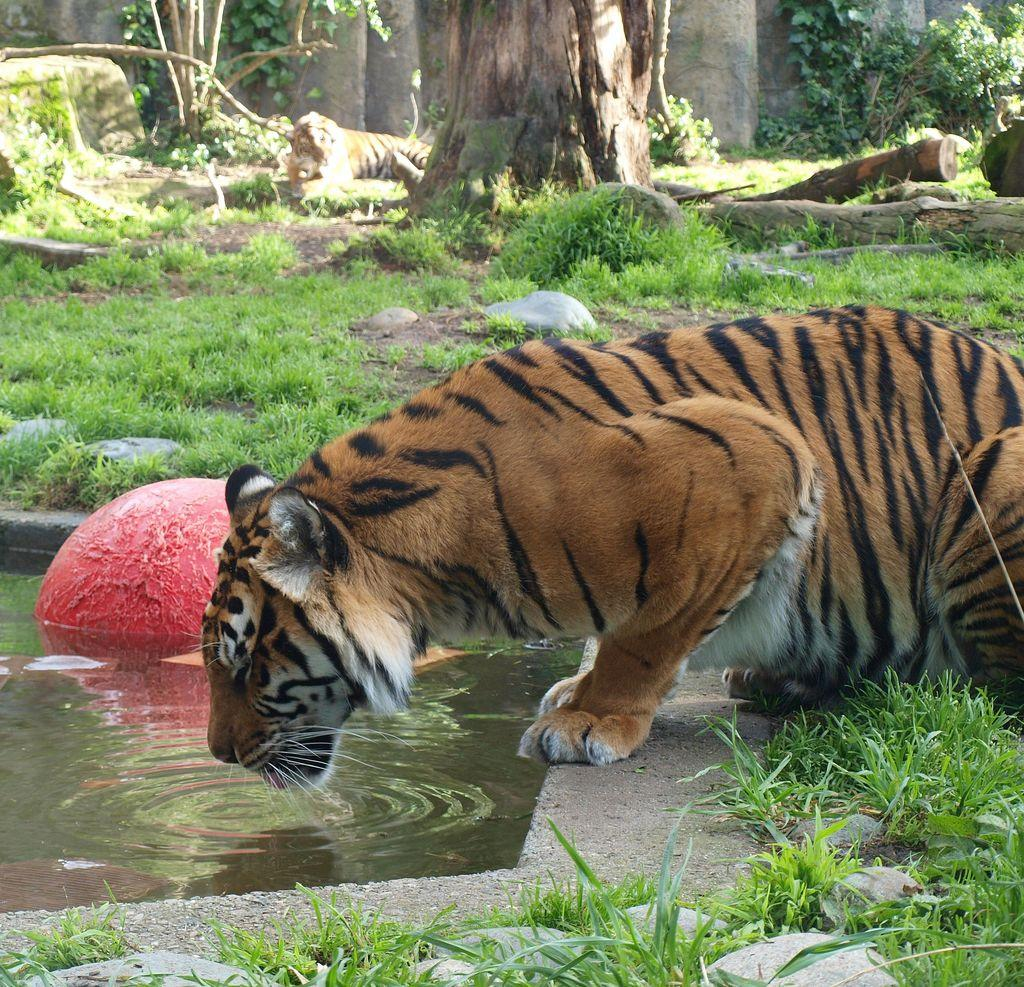What animal can be seen in the image? There is a tiger in the image. What is the tiger doing in the image? The tiger is drinking water from a pond. What type of terrain is visible in the image? There are stones, grass, and trees visible in the image. Can you describe the second tiger in the image? There is another tiger sitting under a tree in the image. What type of scarf is the tiger wearing in the image? There is no scarf present in the image; tigers do not wear clothing. 